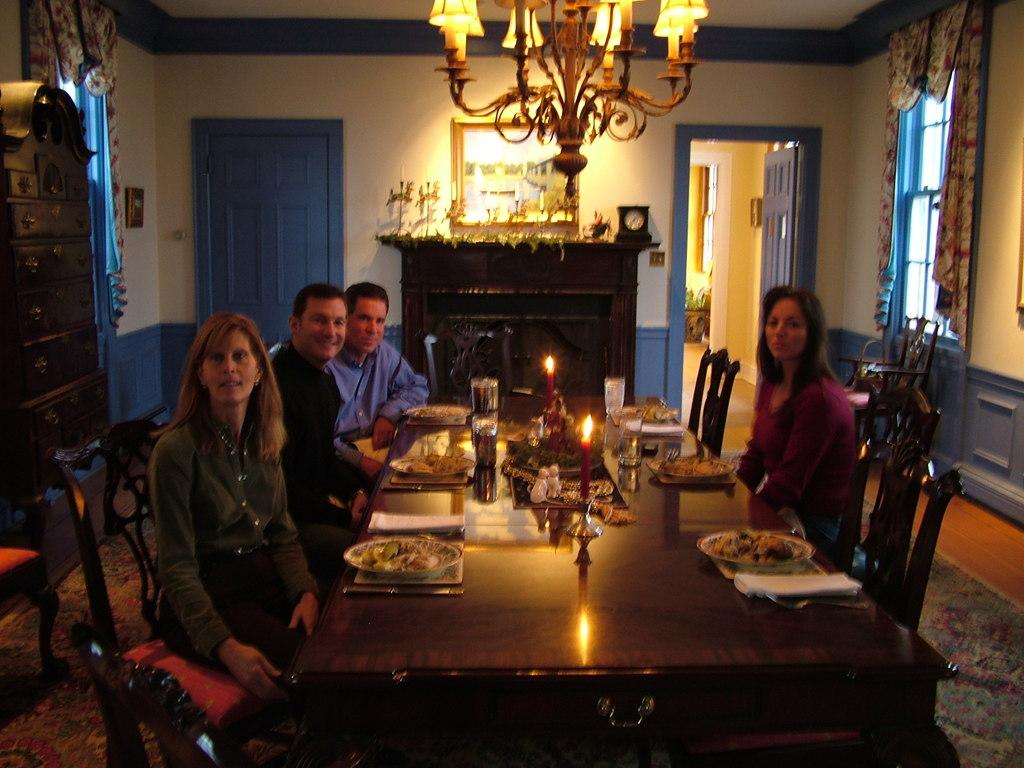How many people are in the image? There are four people in the image, two men and two women. What are the people doing in the image? The people are sitting on chairs. What objects can be seen on the table in the image? There are candles on a table in the image. What architectural features are visible in the background of the image? There is a wall and a door in the background of the image. What type of lighting fixture is visible at the top of the image? There is a chandelier visible at the top of the image. What type of seashore can be seen in the image? There is no seashore present in the image; it features people sitting on chairs with candles on a table and a chandelier. Can you tell me how many kisses the beginner has given in the image? There is no kissing or beginners mentioned in the image; it simply shows people sitting on chairs with candles on a table and a chandelier. 